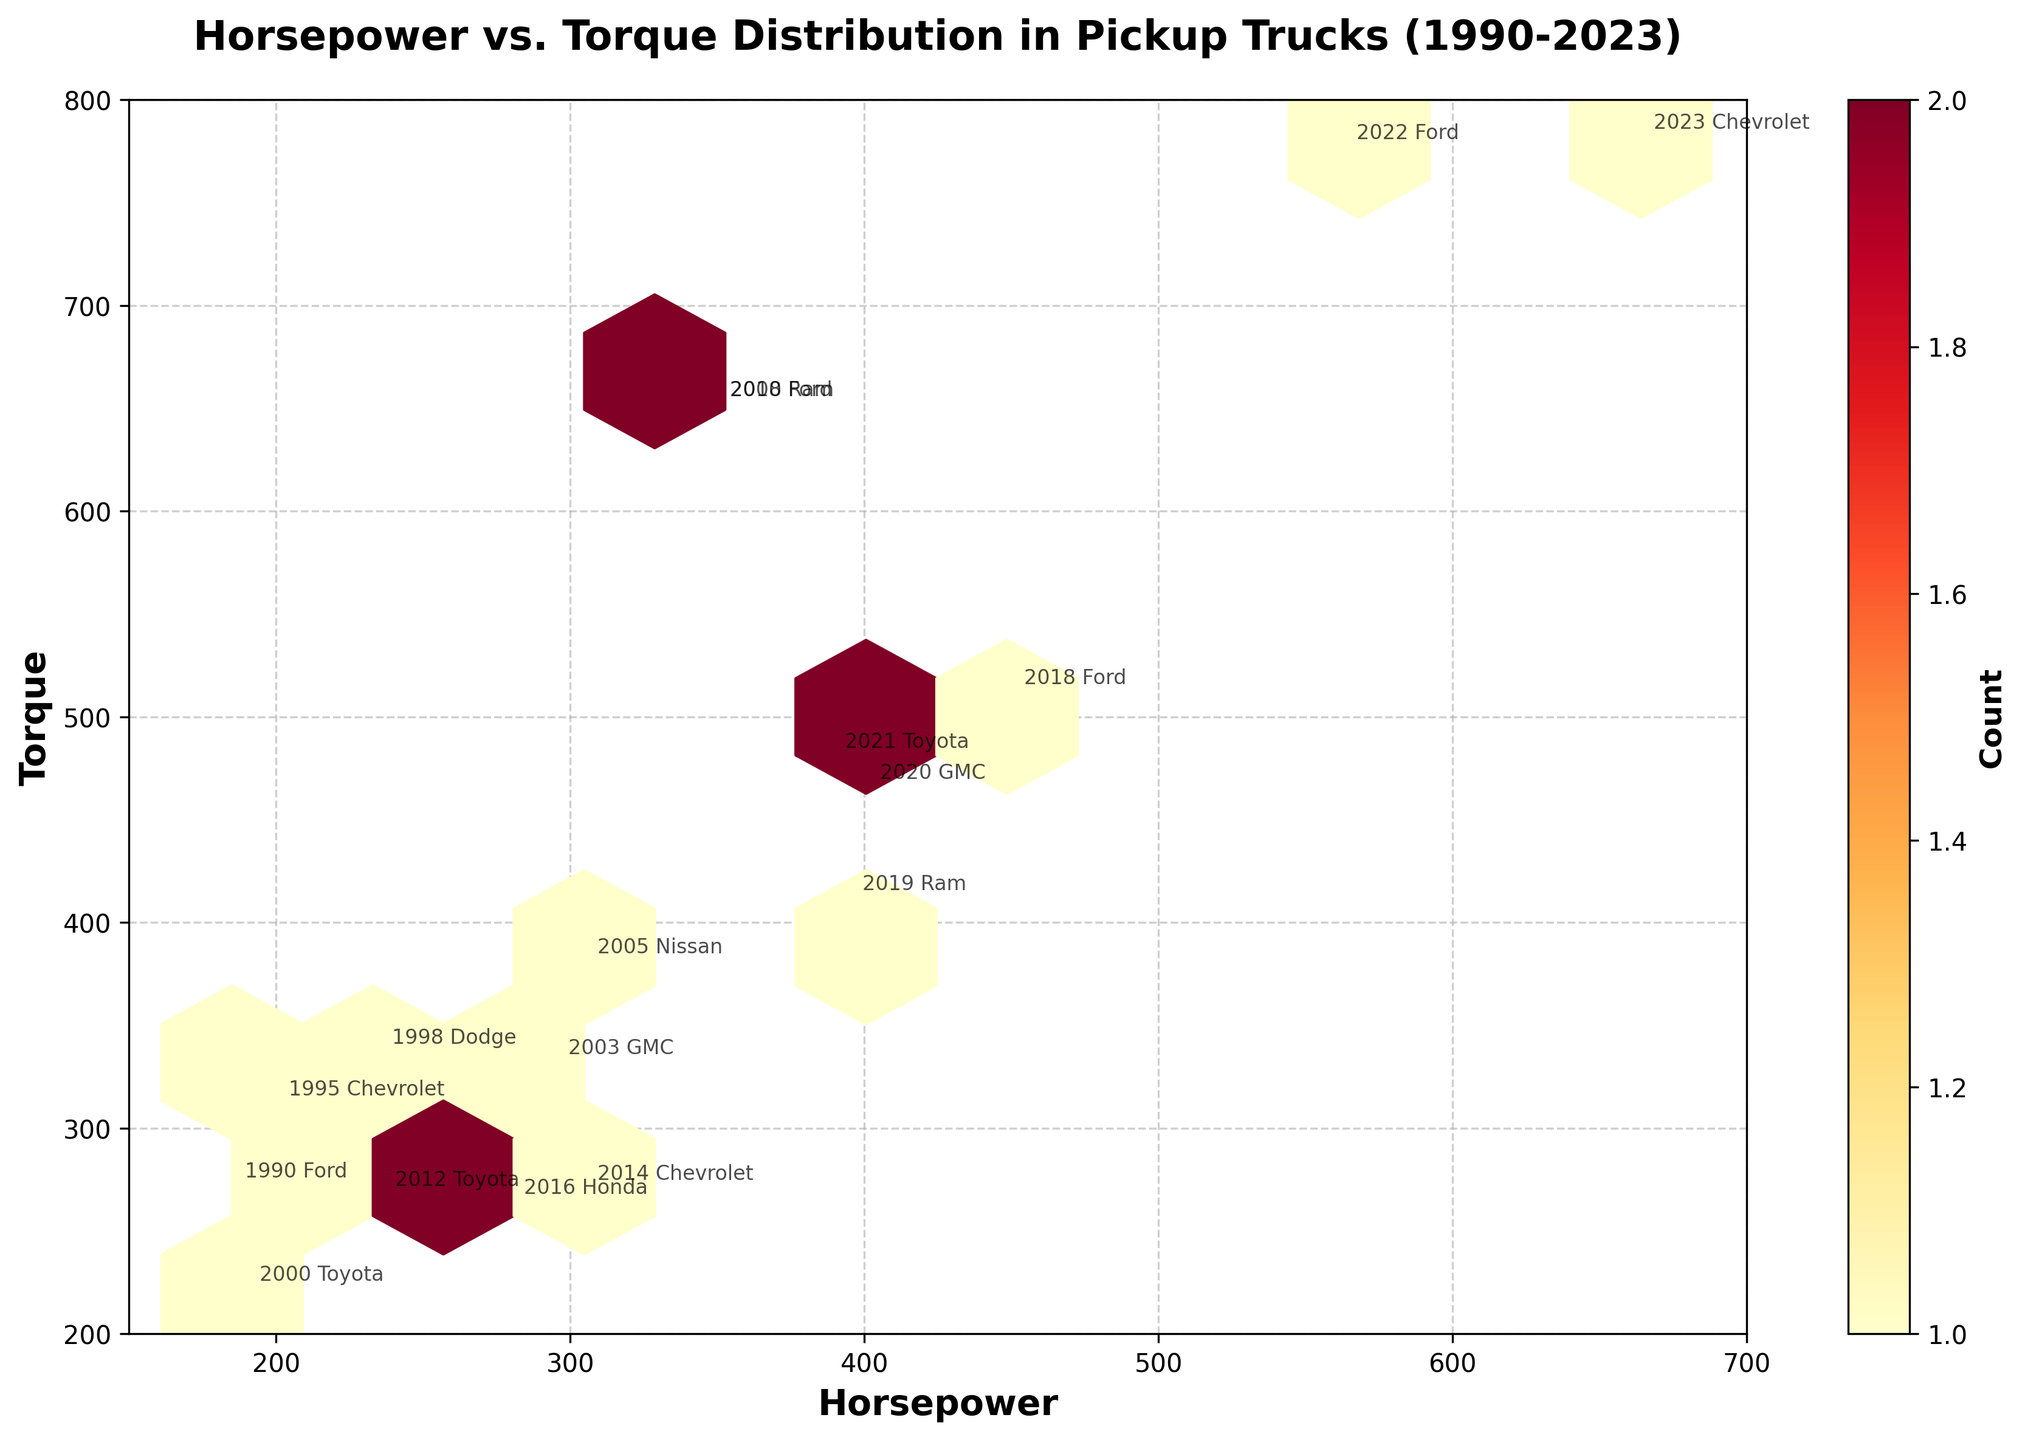How many data points are plotted on the hexbin plot? The hexbin plot typically uses color intensity to demonstrate the number of observations within each bin. By viewing the plot and counting the data points or annotations, we see there are 17 data points in the plot.
Answer: 17 What are the limits of the x and y axes? By inspecting the plot, we can see the labels and range of the axes. The x-axis (Horsepower) ranges from 150 to 700, and the y-axis (Torque) ranges from 200 to 800.
Answer: x-axis: 150-700, y-axis: 200-800 What pickup truck model has the highest horsepower recorded on the plot? The model with the highest horsepower is identified by looking at the data point located furthest to the right on the x-axis. In this case, the Chevrolet Silverado EV in 2023 has the highest horsepower at 664.
Answer: Chevrolet Silverado EV (2023) Which truck has roughly the same horsepower (-5) and torque (around 650) in two different years, and identify the years? By looking at the hexbin plot where two annotations are close to each other with similar horsepower and torque, it's clear that the Ford F-250 (2008) and Ram 2500 (2010) have roughly the same horsepower (~350) and torque (~650).
Answer: Ford F-250 (2008), Ram 2500 (2010) What is the color gradient representing, and which color indicates the highest concentration of data points? The color gradient represents the count of data points within each hexagonal bin. The color map 'YlOrRd' people uses indicates that the highest concentration of data points is displayed in the darkest red color.
Answer: Dark red What is the median horsepower of the pickup trucks shown in the hexbin plot? To find the median horsepower, list all horsepower values, order them, and identify the middle value. The sorted values: 185, 190, 200, 235, 236, 280, 295, 305, 305, 350, 350, 389, 395, 401, 450, 563, 664. The middle value is 305.
Answer: 305 What is the relationship between horsepower and torque according to the plot? Generally, looking at the distribution of the hexbin plot, there is a positive correlation between horsepower and torque; as horsepower increases, torque also increases.
Answer: Positive correlation Which make appears most frequently in the dataset? By counting the number of annotations for each make provided in the plot's points, Ford makes a frequent appearance, followed by Chevrolet and Toyota.
Answer: Ford What year corresponds to the highest torque value on the plot? By locating the highest data point on the y-axis, we can determine the year. The highest torque value of 780 corresponds to the year 2023 with the Chevrolet Silverado EV.
Answer: 2023 What can you infer about the trend in horsepower and torque of pickup trucks from 1990 to 2023? By observing the overall spread of the data points and their progression from 1990 to 2023, there is a noticeable trend of an increase in both horsepower and torque over the years, indicating improvements in engine performance and power for pickup trucks.
Answer: Increase in both horsepower and torque 